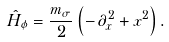<formula> <loc_0><loc_0><loc_500><loc_500>\hat { H } _ { \phi } = \frac { m _ { \sigma } } { 2 } \left ( - \, \partial _ { x } ^ { 2 } + x ^ { 2 } \right ) .</formula> 